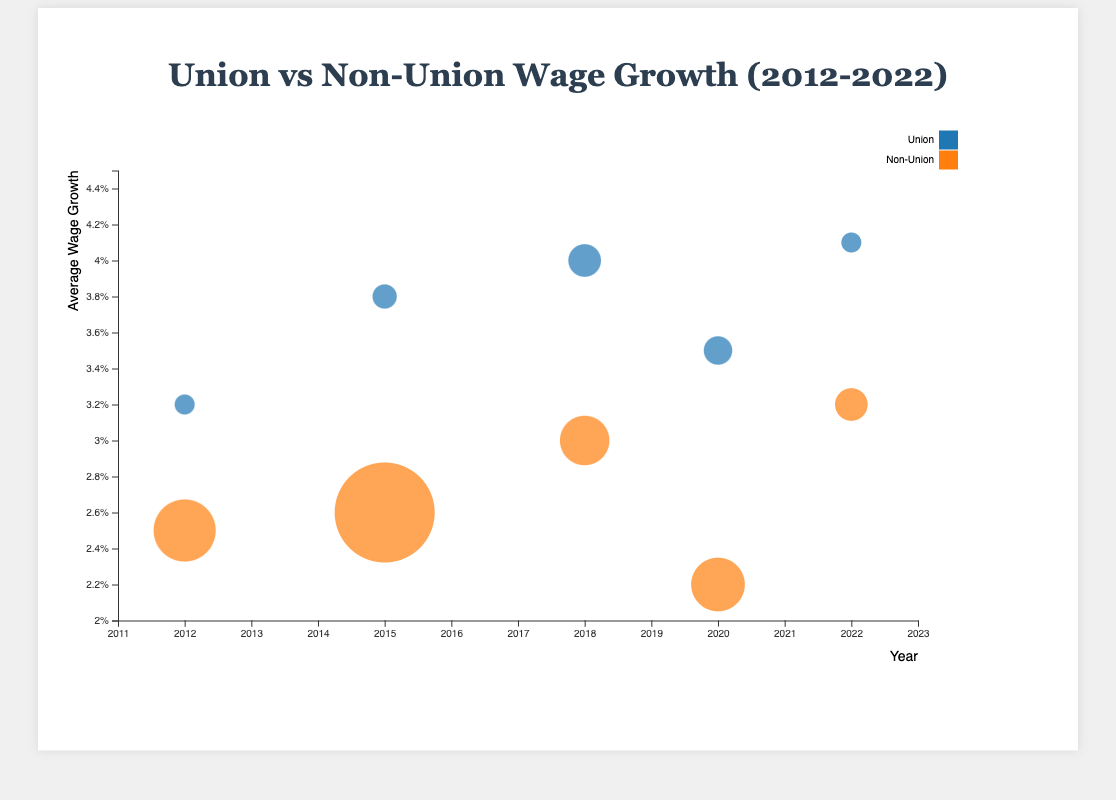What's the overall trend in average wage growth for union workers from 2012 to 2022? Observing the y-axis values for union workers across the years 2012 (3.2%), 2015 (3.8%), 2018 (4.0%), 2020 (3.5%), and 2022 (4.1%), we see a general increase despite a slight dip in 2020.
Answer: General increase What's the largest number of workers represented by a bubble and in which sector are they? The largest bubble size represents 2,400,000 workers in the Healthcare sector for non-union workers in 2015.
Answer: Healthcare, Non-Union, 2015 How does the average wage growth for union workers in the Manufacturing industry in 2018 compare to non-union workers in the same year? The average wage growth for union workers is 4.0%, while for non-union workers it is 3.0% in the Manufacturing industry in 2018.
Answer: 4.0% vs. 3.0% Which industry-year combination shows the smallest average wage growth for non-union workers? The Education sector in 2020 has the smallest average wage growth for non-union workers at 2.2%.
Answer: Education, 2020 How does the average wage growth in the Public Sector in 2022 differ between union and non-unionized workers? In 2022, union workers in the Public Sector have a wage growth of 4.1%, while non-union workers have a 3.2% growth.
Answer: 4.1% vs. 3.2% Which sector has consistently shown higher wage growth for union workers compared to non-union workers? Consistently, in the Construction (2012), Healthcare (2015), Manufacturing (2018), Education (2020), and Public Sector (2022), union workers have higher wage growth than non-union workers.
Answer: All listed sectors What's the average wage growth for union workers across all industries and years presented? Summing up the wage growth percentages for union workers: 3.2 (2012) + 3.8 (2015) + 4.0 (2018) + 3.5 (2020) + 4.1 (2022) = 18.6%. Dividing by the number of years (5): 18.6% / 5 = 3.72%.
Answer: 3.72% How do the sizes of the bubbles representing union vs. non-union workers compare across industries? Non-union worker bubbles are consistently larger than union worker bubbles due to a higher number of non-union workers in every industry and year shown.
Answer: Non-union bubbles larger In which year was the disparity in wage growth between union and non-union workers in the Construction industry the smallest? In 2012, the wage growth disparity in the Construction industry was 3.2% for union workers and 2.5% for non-union workers, a difference of 0.7%. This is the only year shown for the Construction industry.
Answer: 2012 